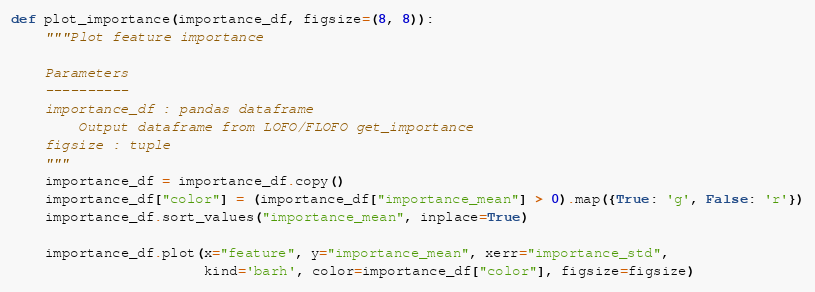<code> <loc_0><loc_0><loc_500><loc_500><_Python_>def plot_importance(importance_df, figsize=(8, 8)):
    """Plot feature importance

    Parameters
    ----------
    importance_df : pandas dataframe
        Output dataframe from LOFO/FLOFO get_importance
    figsize : tuple
    """
    importance_df = importance_df.copy()
    importance_df["color"] = (importance_df["importance_mean"] > 0).map({True: 'g', False: 'r'})
    importance_df.sort_values("importance_mean", inplace=True)

    importance_df.plot(x="feature", y="importance_mean", xerr="importance_std",
                       kind='barh', color=importance_df["color"], figsize=figsize)
</code> 